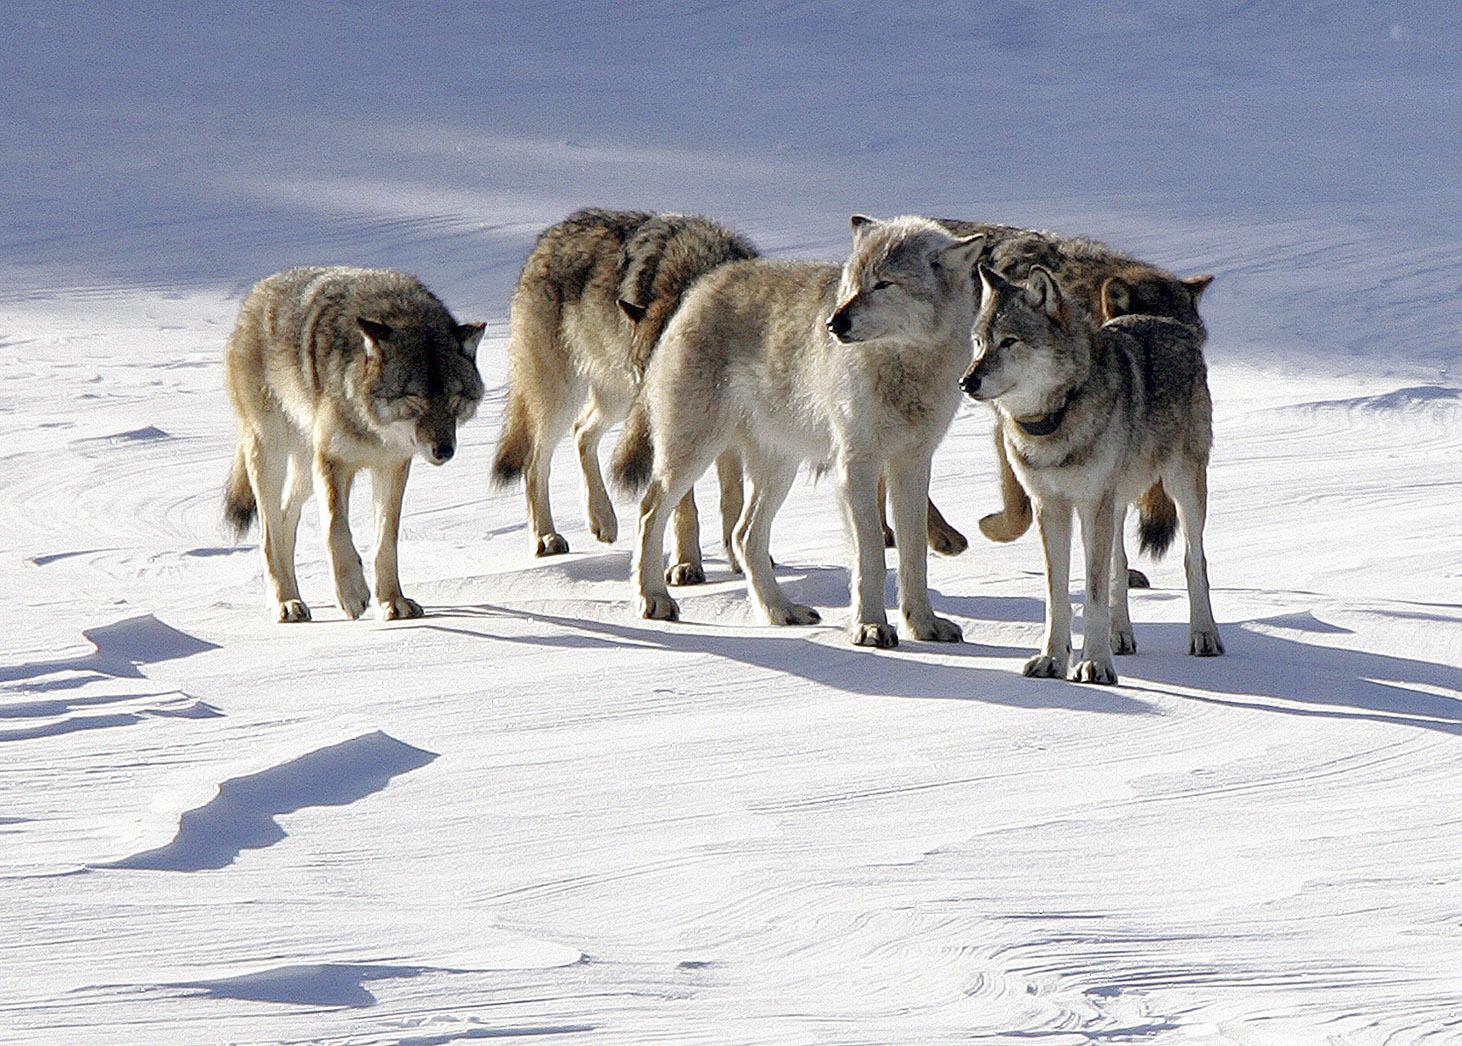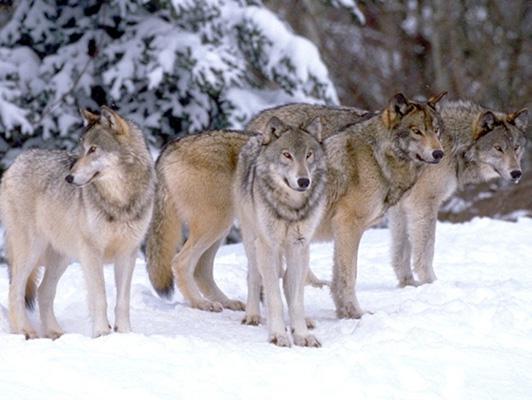The first image is the image on the left, the second image is the image on the right. For the images displayed, is the sentence "An image features exactly three wolves, which look toward the camera." factually correct? Answer yes or no. No. The first image is the image on the left, the second image is the image on the right. Considering the images on both sides, is "The right image contains two or fewer wolves." valid? Answer yes or no. No. 